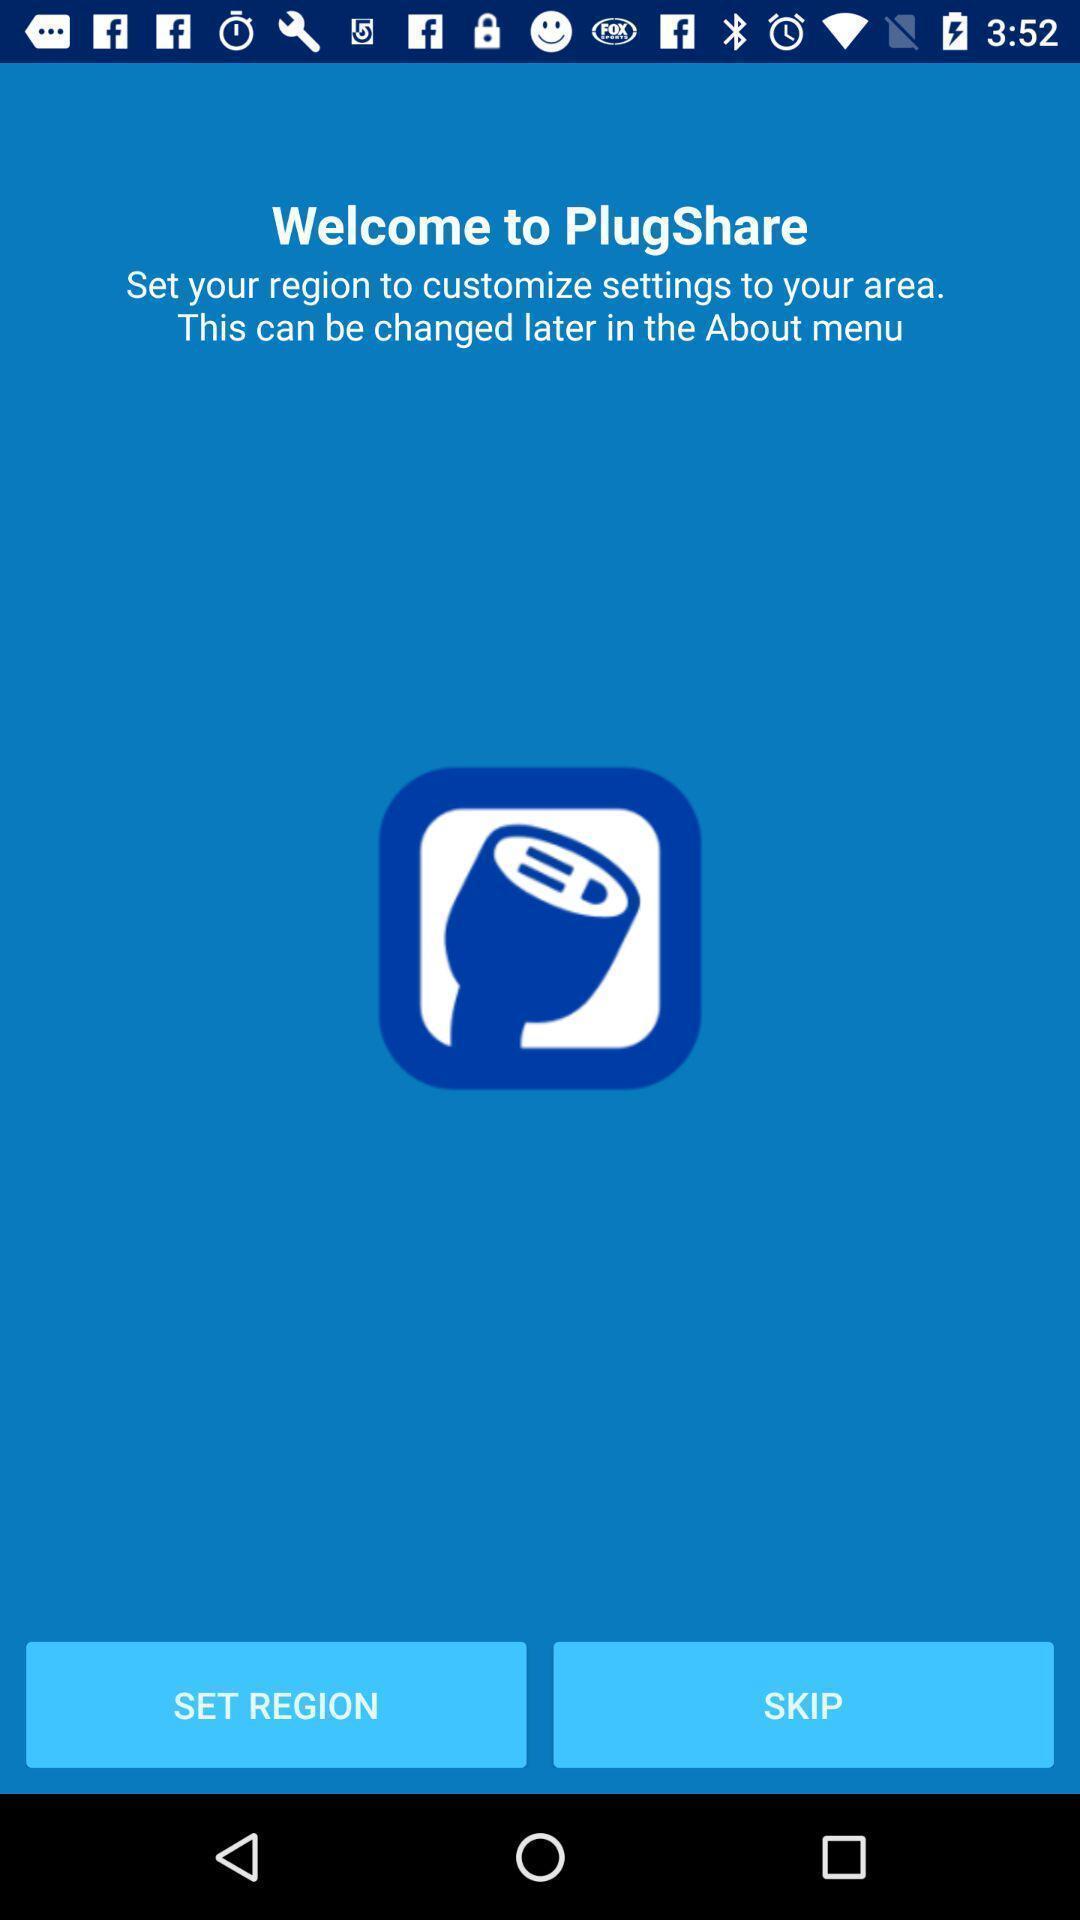Provide a description of this screenshot. Welcoming page of a plugshare. 